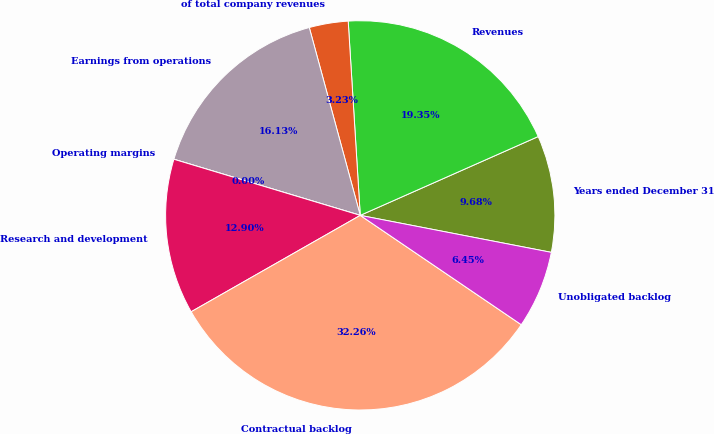Convert chart to OTSL. <chart><loc_0><loc_0><loc_500><loc_500><pie_chart><fcel>Years ended December 31<fcel>Revenues<fcel>of total company revenues<fcel>Earnings from operations<fcel>Operating margins<fcel>Research and development<fcel>Contractual backlog<fcel>Unobligated backlog<nl><fcel>9.68%<fcel>19.35%<fcel>3.23%<fcel>16.13%<fcel>0.0%<fcel>12.9%<fcel>32.26%<fcel>6.45%<nl></chart> 